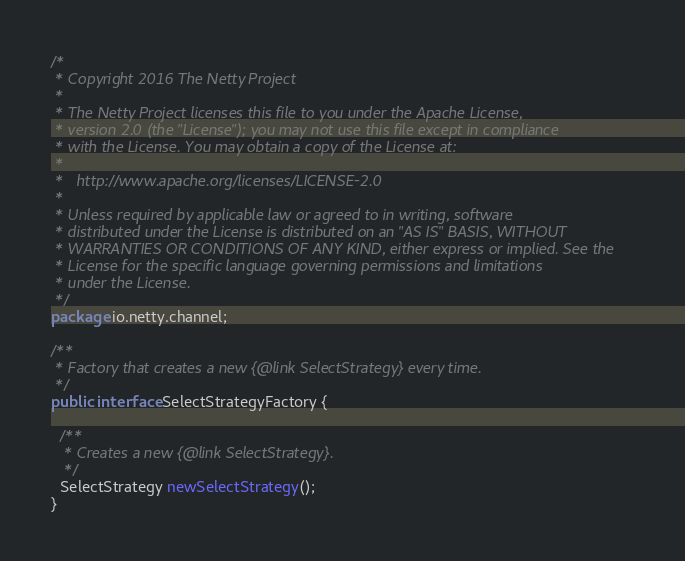Convert code to text. <code><loc_0><loc_0><loc_500><loc_500><_Java_>/*
 * Copyright 2016 The Netty Project
 *
 * The Netty Project licenses this file to you under the Apache License,
 * version 2.0 (the "License"); you may not use this file except in compliance
 * with the License. You may obtain a copy of the License at:
 *
 *   http://www.apache.org/licenses/LICENSE-2.0
 *
 * Unless required by applicable law or agreed to in writing, software
 * distributed under the License is distributed on an "AS IS" BASIS, WITHOUT
 * WARRANTIES OR CONDITIONS OF ANY KIND, either express or implied. See the
 * License for the specific language governing permissions and limitations
 * under the License.
 */
package io.netty.channel;

/**
 * Factory that creates a new {@link SelectStrategy} every time.
 */
public interface SelectStrategyFactory {

  /**
   * Creates a new {@link SelectStrategy}.
   */
  SelectStrategy newSelectStrategy();
}
</code> 